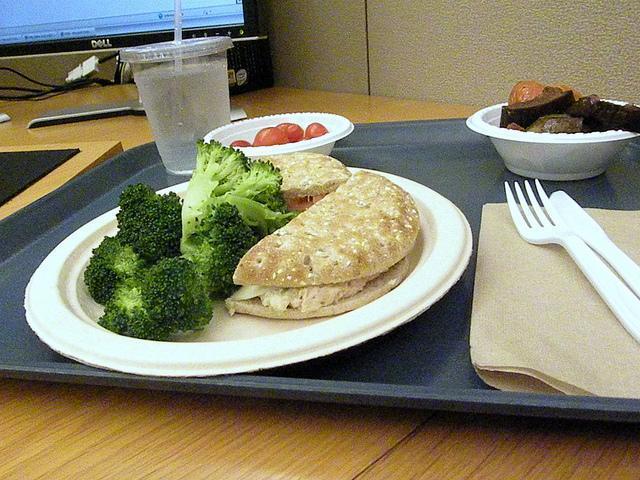How many bowls can be seen?
Give a very brief answer. 2. How many cups are in the picture?
Give a very brief answer. 1. How many broccolis are visible?
Give a very brief answer. 2. How many sandwiches are visible?
Give a very brief answer. 2. 